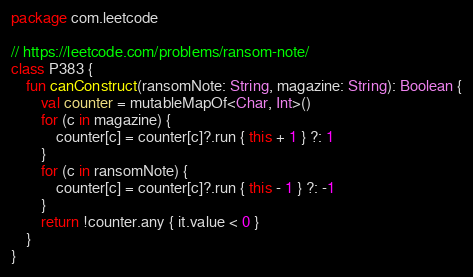Convert code to text. <code><loc_0><loc_0><loc_500><loc_500><_Kotlin_>package com.leetcode

// https://leetcode.com/problems/ransom-note/
class P383 {
    fun canConstruct(ransomNote: String, magazine: String): Boolean {
        val counter = mutableMapOf<Char, Int>()
        for (c in magazine) {
            counter[c] = counter[c]?.run { this + 1 } ?: 1
        }
        for (c in ransomNote) {
            counter[c] = counter[c]?.run { this - 1 } ?: -1
        }
        return !counter.any { it.value < 0 }
    }
}
</code> 